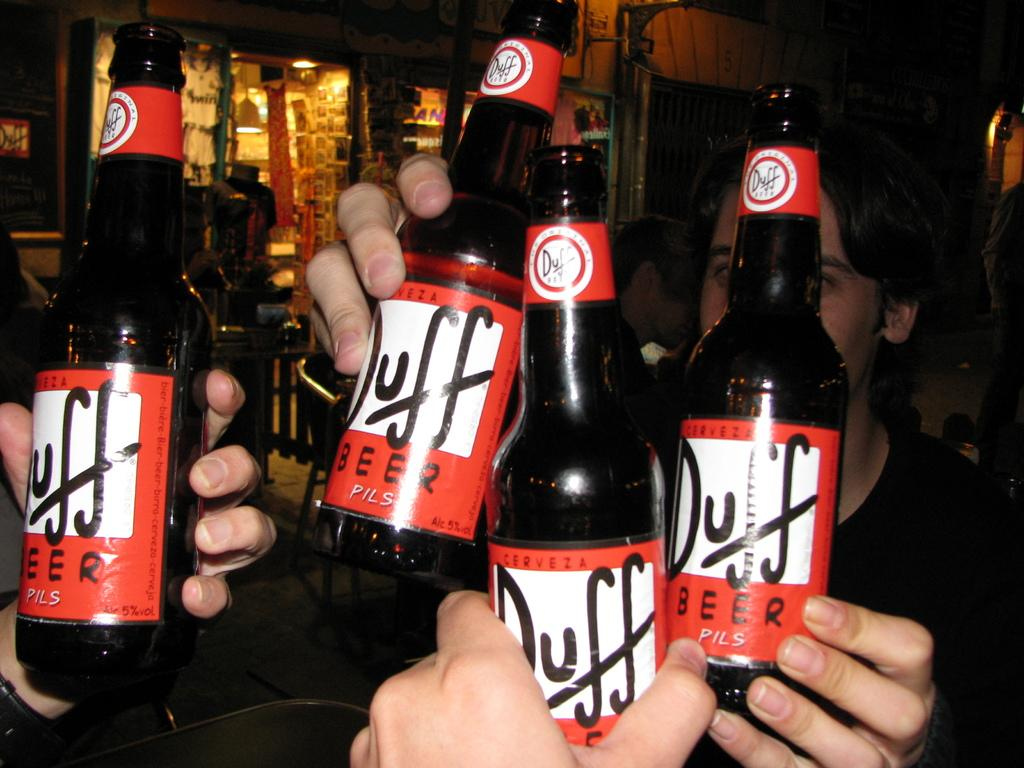<image>
Offer a succinct explanation of the picture presented. Several bottles of Duff Beer are being held up. 